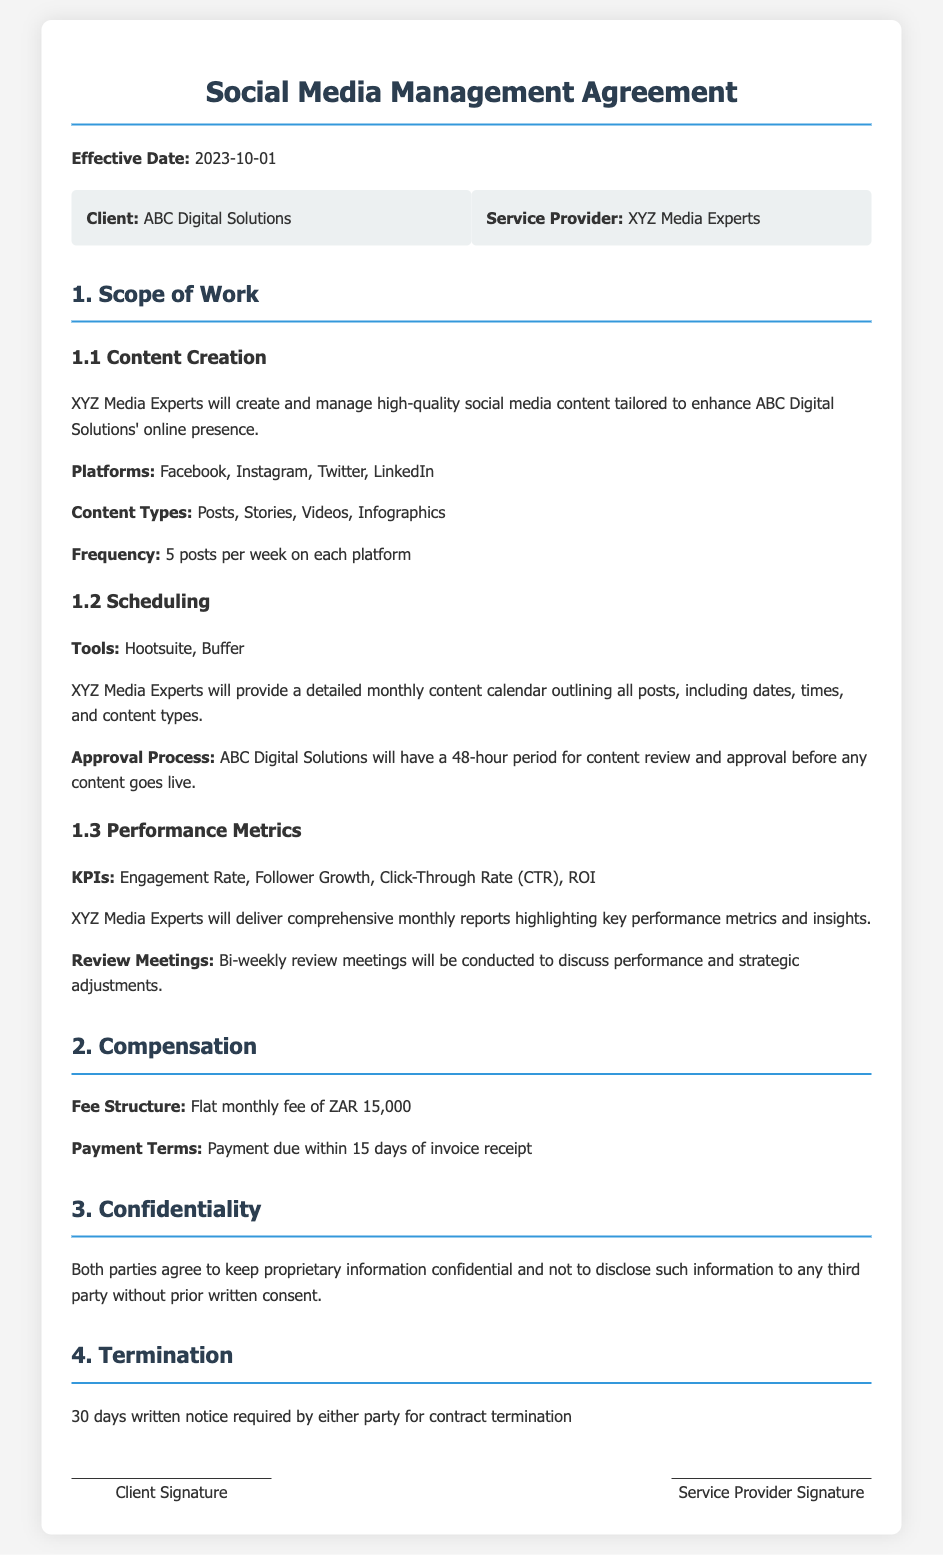What is the effective date of the contract? The effective date is mentioned in the document, specifying when the agreement commences.
Answer: 2023-10-01 Who is the client in this agreement? The document states the name of the client party involved in the agreement.
Answer: ABC Digital Solutions How many posts per week will be created for each platform? The frequency of posts is detailed under the content creation section.
Answer: 5 posts What tools will be used for scheduling? The document specifies the tools that the service provider will utilize for content scheduling.
Answer: Hootsuite, Buffer What is the monthly fee for the services rendered? The fee structure specifies the amount that the client is required to pay monthly.
Answer: ZAR 15,000 What is the review period for content approval? The document outlines a specific time frame for the approval of content by the client.
Answer: 48-hour period How often will performance review meetings occur? The frequency of meetings to discuss performance metrics is stated in the document.
Answer: Bi-weekly What is the notice period required for termination of the contract? The termination section specifies how much notice must be given by either party.
Answer: 30 days 